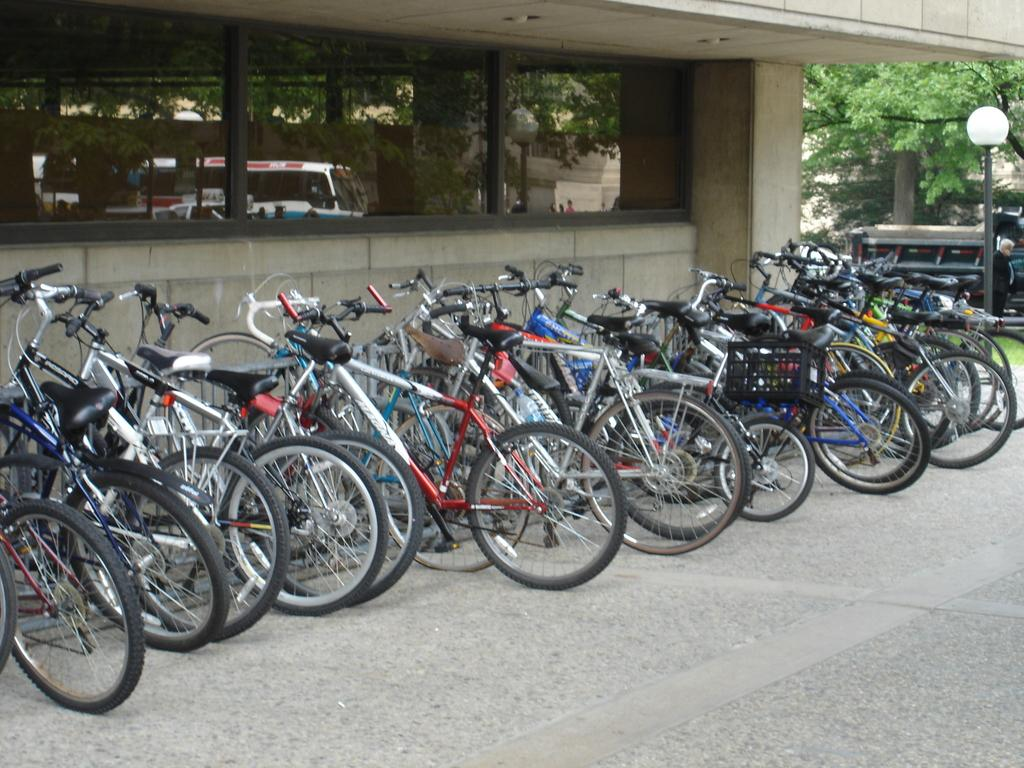What can be seen on the path in the image? There are bicycles on the path in the image. What is the source of light visible in the image? There is a streetlight in the image. Can you describe the person on the right side of the image? There is a person on the right side of the image, but their specific appearance or actions cannot be determined from the provided facts. What can be seen in the background of the image? There are vehicles, trees, and a building visible in the background of the image. What type of print can be seen on the toy in the image? There is no toy present in the image, so it is not possible to determine the type of print on it. What is the person on the right side of the image holding in their hand? The specific actions or objects held by the person on the right side of the image cannot be determined from the provided facts. 